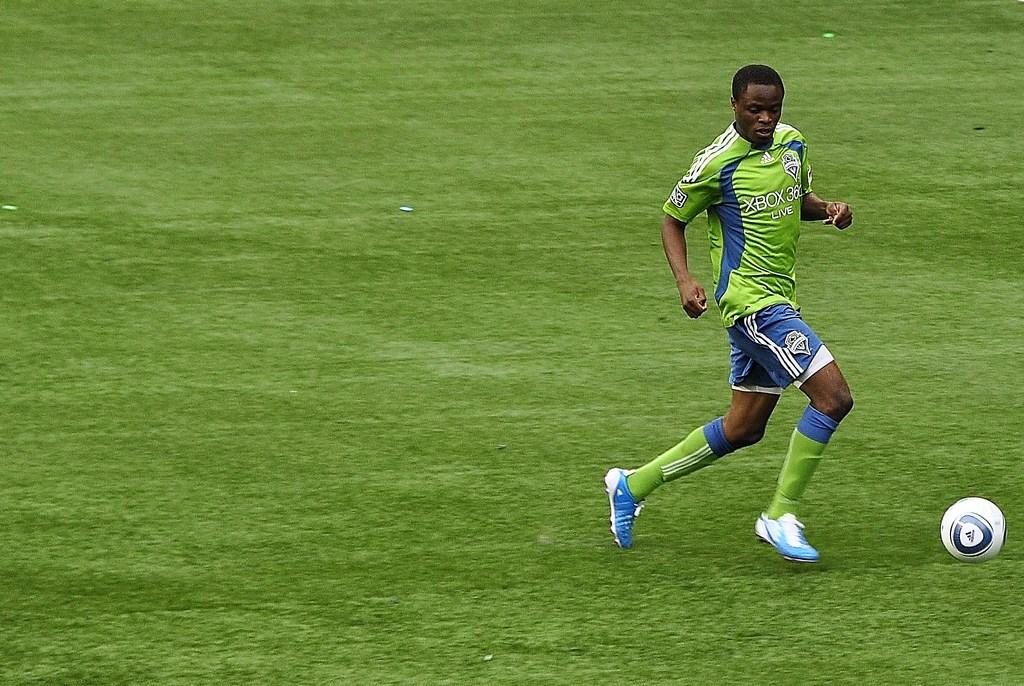<image>
Describe the image concisely. A soccer player runs with the ball wearing an xbox jersey. 